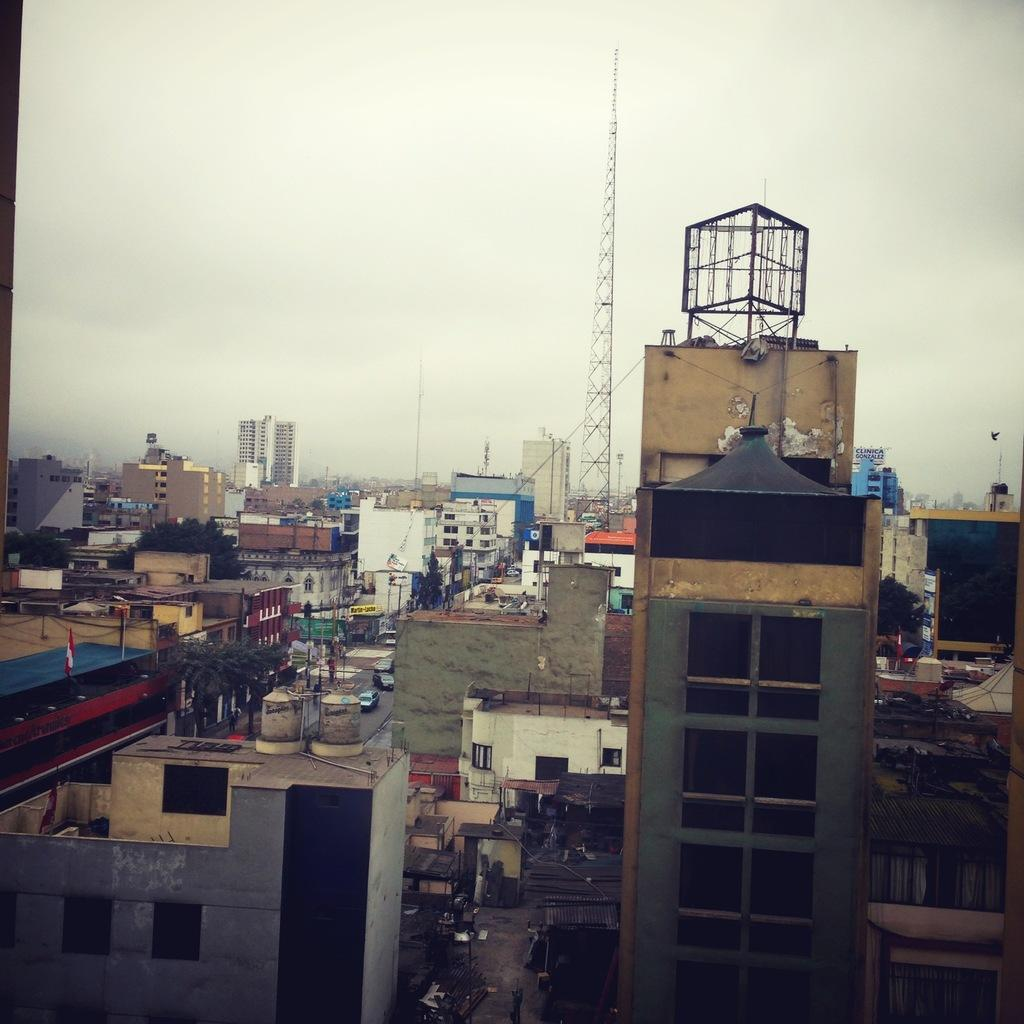What type of structures can be seen in the image? There are buildings in the image. What other objects can be seen in the image? There are poles, vehicles, trees, and a tower in the image. What additional feature is present in the image? There is a flag in the image. What can be seen in the background of the image? The sky is visible in the background of the image. Can you tell me how many chess pieces are on the boat in the image? There is no boat or chess pieces present in the image. What type of attack is being carried out by the vehicles in the image? There is no attack or indication of any conflict in the image; the vehicles are simply parked or driving. 